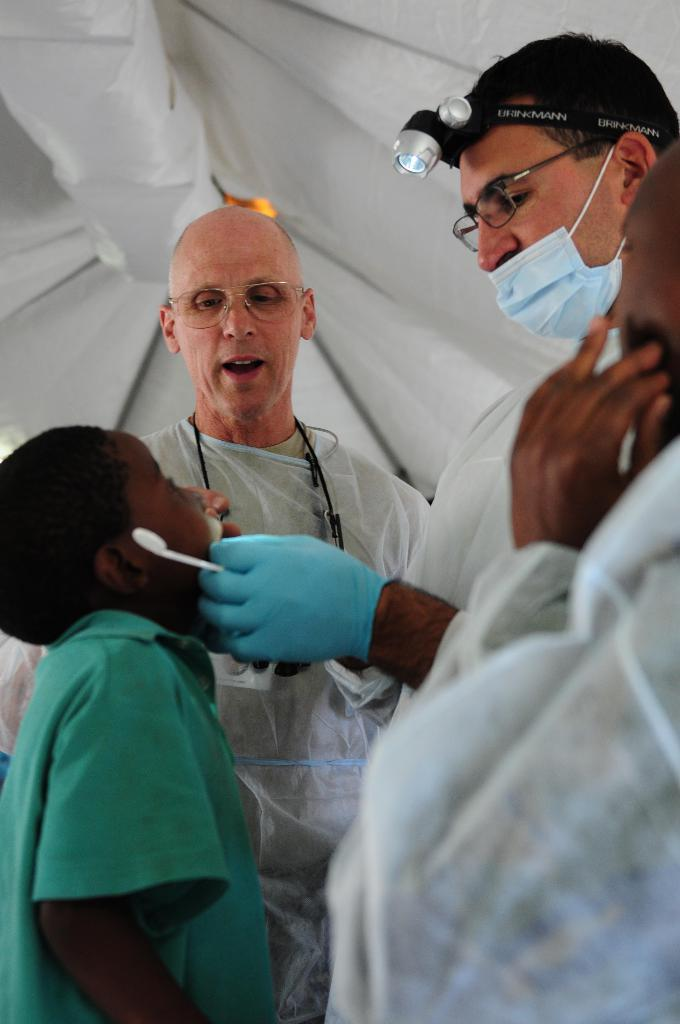How many people are in the image? There are four persons in the image. What can be observed about the appearance of each person? Each person is wearing spectacles. What is the color of the background in the image? The background of the image is white. What type of tools does the carpenter have in the image? There is no carpenter or tools present in the image. What might have caused a surprise in the image? There is no indication of a surprise or any related events in the image. 